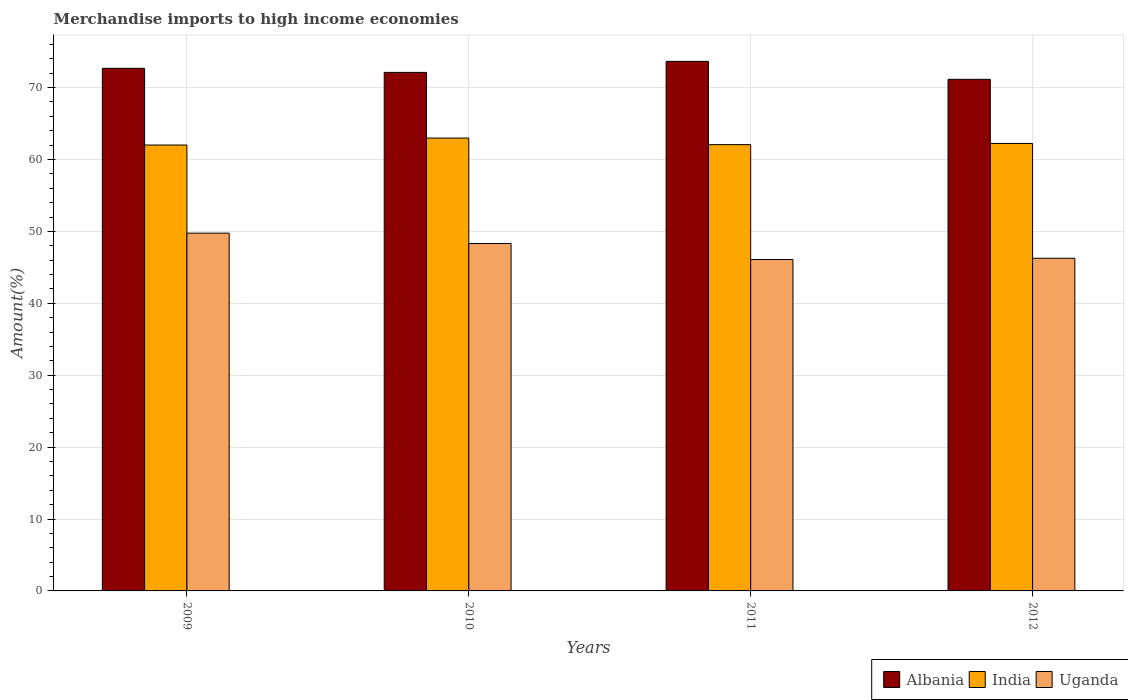How many different coloured bars are there?
Keep it short and to the point. 3. How many groups of bars are there?
Your response must be concise. 4. Are the number of bars per tick equal to the number of legend labels?
Your answer should be very brief. Yes. How many bars are there on the 3rd tick from the left?
Offer a terse response. 3. How many bars are there on the 3rd tick from the right?
Offer a very short reply. 3. What is the label of the 4th group of bars from the left?
Your response must be concise. 2012. In how many cases, is the number of bars for a given year not equal to the number of legend labels?
Offer a very short reply. 0. What is the percentage of amount earned from merchandise imports in Uganda in 2012?
Keep it short and to the point. 46.26. Across all years, what is the maximum percentage of amount earned from merchandise imports in Uganda?
Your answer should be compact. 49.75. Across all years, what is the minimum percentage of amount earned from merchandise imports in India?
Ensure brevity in your answer.  62.01. In which year was the percentage of amount earned from merchandise imports in India maximum?
Offer a very short reply. 2010. What is the total percentage of amount earned from merchandise imports in Albania in the graph?
Offer a terse response. 289.58. What is the difference between the percentage of amount earned from merchandise imports in India in 2010 and that in 2012?
Your answer should be very brief. 0.75. What is the difference between the percentage of amount earned from merchandise imports in India in 2011 and the percentage of amount earned from merchandise imports in Uganda in 2010?
Offer a terse response. 13.75. What is the average percentage of amount earned from merchandise imports in Albania per year?
Keep it short and to the point. 72.4. In the year 2009, what is the difference between the percentage of amount earned from merchandise imports in Uganda and percentage of amount earned from merchandise imports in India?
Your answer should be very brief. -12.26. In how many years, is the percentage of amount earned from merchandise imports in India greater than 2 %?
Provide a short and direct response. 4. What is the ratio of the percentage of amount earned from merchandise imports in Uganda in 2009 to that in 2012?
Keep it short and to the point. 1.08. Is the percentage of amount earned from merchandise imports in Uganda in 2009 less than that in 2010?
Provide a succinct answer. No. Is the difference between the percentage of amount earned from merchandise imports in Uganda in 2009 and 2011 greater than the difference between the percentage of amount earned from merchandise imports in India in 2009 and 2011?
Provide a short and direct response. Yes. What is the difference between the highest and the second highest percentage of amount earned from merchandise imports in Uganda?
Offer a very short reply. 1.44. What is the difference between the highest and the lowest percentage of amount earned from merchandise imports in India?
Keep it short and to the point. 0.97. In how many years, is the percentage of amount earned from merchandise imports in India greater than the average percentage of amount earned from merchandise imports in India taken over all years?
Your answer should be compact. 1. Is it the case that in every year, the sum of the percentage of amount earned from merchandise imports in Uganda and percentage of amount earned from merchandise imports in Albania is greater than the percentage of amount earned from merchandise imports in India?
Your answer should be compact. Yes. How many years are there in the graph?
Provide a succinct answer. 4. What is the difference between two consecutive major ticks on the Y-axis?
Ensure brevity in your answer.  10. Does the graph contain any zero values?
Make the answer very short. No. Does the graph contain grids?
Give a very brief answer. Yes. Where does the legend appear in the graph?
Your response must be concise. Bottom right. How are the legend labels stacked?
Provide a succinct answer. Horizontal. What is the title of the graph?
Your answer should be very brief. Merchandise imports to high income economies. Does "Romania" appear as one of the legend labels in the graph?
Your answer should be compact. No. What is the label or title of the Y-axis?
Offer a terse response. Amount(%). What is the Amount(%) of Albania in 2009?
Provide a succinct answer. 72.68. What is the Amount(%) in India in 2009?
Ensure brevity in your answer.  62.01. What is the Amount(%) of Uganda in 2009?
Your answer should be compact. 49.75. What is the Amount(%) of Albania in 2010?
Make the answer very short. 72.11. What is the Amount(%) in India in 2010?
Your answer should be compact. 62.98. What is the Amount(%) of Uganda in 2010?
Ensure brevity in your answer.  48.32. What is the Amount(%) of Albania in 2011?
Offer a terse response. 73.65. What is the Amount(%) of India in 2011?
Provide a short and direct response. 62.06. What is the Amount(%) of Uganda in 2011?
Give a very brief answer. 46.09. What is the Amount(%) of Albania in 2012?
Offer a very short reply. 71.15. What is the Amount(%) of India in 2012?
Give a very brief answer. 62.23. What is the Amount(%) of Uganda in 2012?
Offer a very short reply. 46.26. Across all years, what is the maximum Amount(%) of Albania?
Make the answer very short. 73.65. Across all years, what is the maximum Amount(%) in India?
Ensure brevity in your answer.  62.98. Across all years, what is the maximum Amount(%) of Uganda?
Ensure brevity in your answer.  49.75. Across all years, what is the minimum Amount(%) of Albania?
Your answer should be very brief. 71.15. Across all years, what is the minimum Amount(%) in India?
Your answer should be very brief. 62.01. Across all years, what is the minimum Amount(%) in Uganda?
Ensure brevity in your answer.  46.09. What is the total Amount(%) in Albania in the graph?
Your answer should be very brief. 289.58. What is the total Amount(%) in India in the graph?
Give a very brief answer. 249.28. What is the total Amount(%) in Uganda in the graph?
Give a very brief answer. 190.42. What is the difference between the Amount(%) in Albania in 2009 and that in 2010?
Your answer should be compact. 0.57. What is the difference between the Amount(%) in India in 2009 and that in 2010?
Make the answer very short. -0.97. What is the difference between the Amount(%) in Uganda in 2009 and that in 2010?
Your answer should be very brief. 1.44. What is the difference between the Amount(%) in Albania in 2009 and that in 2011?
Your response must be concise. -0.97. What is the difference between the Amount(%) of India in 2009 and that in 2011?
Offer a very short reply. -0.05. What is the difference between the Amount(%) in Uganda in 2009 and that in 2011?
Provide a succinct answer. 3.67. What is the difference between the Amount(%) of Albania in 2009 and that in 2012?
Offer a terse response. 1.53. What is the difference between the Amount(%) in India in 2009 and that in 2012?
Provide a short and direct response. -0.22. What is the difference between the Amount(%) of Uganda in 2009 and that in 2012?
Give a very brief answer. 3.49. What is the difference between the Amount(%) in Albania in 2010 and that in 2011?
Ensure brevity in your answer.  -1.54. What is the difference between the Amount(%) of India in 2010 and that in 2011?
Offer a terse response. 0.91. What is the difference between the Amount(%) in Uganda in 2010 and that in 2011?
Your response must be concise. 2.23. What is the difference between the Amount(%) of Albania in 2010 and that in 2012?
Your answer should be very brief. 0.96. What is the difference between the Amount(%) in India in 2010 and that in 2012?
Your answer should be very brief. 0.75. What is the difference between the Amount(%) of Uganda in 2010 and that in 2012?
Provide a short and direct response. 2.05. What is the difference between the Amount(%) of Albania in 2011 and that in 2012?
Keep it short and to the point. 2.5. What is the difference between the Amount(%) in India in 2011 and that in 2012?
Your answer should be compact. -0.16. What is the difference between the Amount(%) of Uganda in 2011 and that in 2012?
Make the answer very short. -0.18. What is the difference between the Amount(%) in Albania in 2009 and the Amount(%) in India in 2010?
Provide a short and direct response. 9.7. What is the difference between the Amount(%) in Albania in 2009 and the Amount(%) in Uganda in 2010?
Offer a terse response. 24.36. What is the difference between the Amount(%) in India in 2009 and the Amount(%) in Uganda in 2010?
Give a very brief answer. 13.7. What is the difference between the Amount(%) of Albania in 2009 and the Amount(%) of India in 2011?
Your response must be concise. 10.61. What is the difference between the Amount(%) of Albania in 2009 and the Amount(%) of Uganda in 2011?
Offer a terse response. 26.59. What is the difference between the Amount(%) of India in 2009 and the Amount(%) of Uganda in 2011?
Give a very brief answer. 15.92. What is the difference between the Amount(%) in Albania in 2009 and the Amount(%) in India in 2012?
Give a very brief answer. 10.45. What is the difference between the Amount(%) of Albania in 2009 and the Amount(%) of Uganda in 2012?
Give a very brief answer. 26.41. What is the difference between the Amount(%) of India in 2009 and the Amount(%) of Uganda in 2012?
Your answer should be compact. 15.75. What is the difference between the Amount(%) in Albania in 2010 and the Amount(%) in India in 2011?
Offer a very short reply. 10.05. What is the difference between the Amount(%) in Albania in 2010 and the Amount(%) in Uganda in 2011?
Provide a succinct answer. 26.02. What is the difference between the Amount(%) of India in 2010 and the Amount(%) of Uganda in 2011?
Provide a short and direct response. 16.89. What is the difference between the Amount(%) of Albania in 2010 and the Amount(%) of India in 2012?
Make the answer very short. 9.88. What is the difference between the Amount(%) in Albania in 2010 and the Amount(%) in Uganda in 2012?
Keep it short and to the point. 25.85. What is the difference between the Amount(%) of India in 2010 and the Amount(%) of Uganda in 2012?
Provide a succinct answer. 16.71. What is the difference between the Amount(%) of Albania in 2011 and the Amount(%) of India in 2012?
Make the answer very short. 11.42. What is the difference between the Amount(%) of Albania in 2011 and the Amount(%) of Uganda in 2012?
Your answer should be very brief. 27.38. What is the difference between the Amount(%) of India in 2011 and the Amount(%) of Uganda in 2012?
Offer a terse response. 15.8. What is the average Amount(%) in Albania per year?
Provide a succinct answer. 72.4. What is the average Amount(%) of India per year?
Provide a succinct answer. 62.32. What is the average Amount(%) of Uganda per year?
Provide a short and direct response. 47.6. In the year 2009, what is the difference between the Amount(%) of Albania and Amount(%) of India?
Provide a short and direct response. 10.67. In the year 2009, what is the difference between the Amount(%) of Albania and Amount(%) of Uganda?
Offer a very short reply. 22.92. In the year 2009, what is the difference between the Amount(%) of India and Amount(%) of Uganda?
Your answer should be very brief. 12.26. In the year 2010, what is the difference between the Amount(%) of Albania and Amount(%) of India?
Ensure brevity in your answer.  9.13. In the year 2010, what is the difference between the Amount(%) of Albania and Amount(%) of Uganda?
Provide a succinct answer. 23.8. In the year 2010, what is the difference between the Amount(%) in India and Amount(%) in Uganda?
Your answer should be very brief. 14.66. In the year 2011, what is the difference between the Amount(%) in Albania and Amount(%) in India?
Offer a very short reply. 11.58. In the year 2011, what is the difference between the Amount(%) of Albania and Amount(%) of Uganda?
Keep it short and to the point. 27.56. In the year 2011, what is the difference between the Amount(%) of India and Amount(%) of Uganda?
Keep it short and to the point. 15.98. In the year 2012, what is the difference between the Amount(%) in Albania and Amount(%) in India?
Offer a very short reply. 8.92. In the year 2012, what is the difference between the Amount(%) of Albania and Amount(%) of Uganda?
Keep it short and to the point. 24.88. In the year 2012, what is the difference between the Amount(%) of India and Amount(%) of Uganda?
Give a very brief answer. 15.97. What is the ratio of the Amount(%) in Albania in 2009 to that in 2010?
Provide a succinct answer. 1.01. What is the ratio of the Amount(%) in India in 2009 to that in 2010?
Ensure brevity in your answer.  0.98. What is the ratio of the Amount(%) of Uganda in 2009 to that in 2010?
Your answer should be compact. 1.03. What is the ratio of the Amount(%) of Albania in 2009 to that in 2011?
Provide a succinct answer. 0.99. What is the ratio of the Amount(%) in Uganda in 2009 to that in 2011?
Provide a succinct answer. 1.08. What is the ratio of the Amount(%) of Albania in 2009 to that in 2012?
Your response must be concise. 1.02. What is the ratio of the Amount(%) of Uganda in 2009 to that in 2012?
Your answer should be very brief. 1.08. What is the ratio of the Amount(%) in Albania in 2010 to that in 2011?
Your answer should be compact. 0.98. What is the ratio of the Amount(%) of India in 2010 to that in 2011?
Keep it short and to the point. 1.01. What is the ratio of the Amount(%) in Uganda in 2010 to that in 2011?
Offer a very short reply. 1.05. What is the ratio of the Amount(%) of Albania in 2010 to that in 2012?
Ensure brevity in your answer.  1.01. What is the ratio of the Amount(%) in Uganda in 2010 to that in 2012?
Offer a very short reply. 1.04. What is the ratio of the Amount(%) in Albania in 2011 to that in 2012?
Keep it short and to the point. 1.04. What is the ratio of the Amount(%) of India in 2011 to that in 2012?
Provide a succinct answer. 1. What is the ratio of the Amount(%) of Uganda in 2011 to that in 2012?
Provide a short and direct response. 1. What is the difference between the highest and the second highest Amount(%) in Albania?
Offer a terse response. 0.97. What is the difference between the highest and the second highest Amount(%) in India?
Offer a very short reply. 0.75. What is the difference between the highest and the second highest Amount(%) in Uganda?
Provide a succinct answer. 1.44. What is the difference between the highest and the lowest Amount(%) in Albania?
Ensure brevity in your answer.  2.5. What is the difference between the highest and the lowest Amount(%) in India?
Offer a terse response. 0.97. What is the difference between the highest and the lowest Amount(%) in Uganda?
Provide a succinct answer. 3.67. 